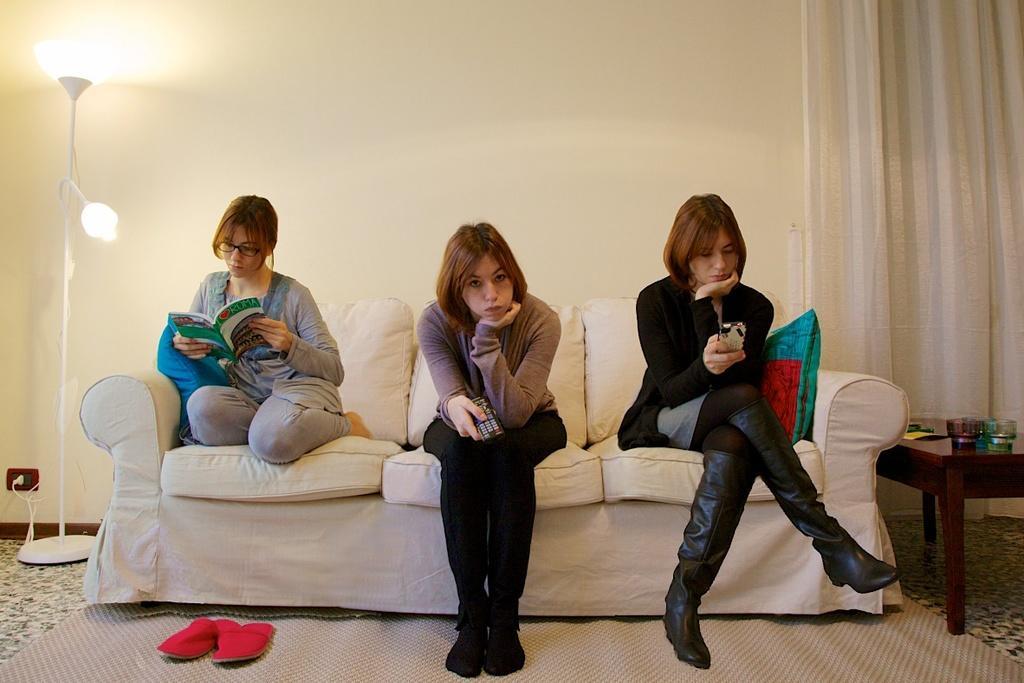Could you give a brief overview of what you see in this image? This picture is taken in a room, there is a sofa which is in white color, on that sofa there are some girls sitting on the sofa, in the left side there is a girl sitting and she is reading a book, in the middle there is a girl sitting and she is holding a remote, in the right side there is a girl sitting and she is using mobile, in the right side corner there is a table which is in brown color, in the left side there is a light which is in white color, in the background there is a yellow color wall and there is a white color curtain. 